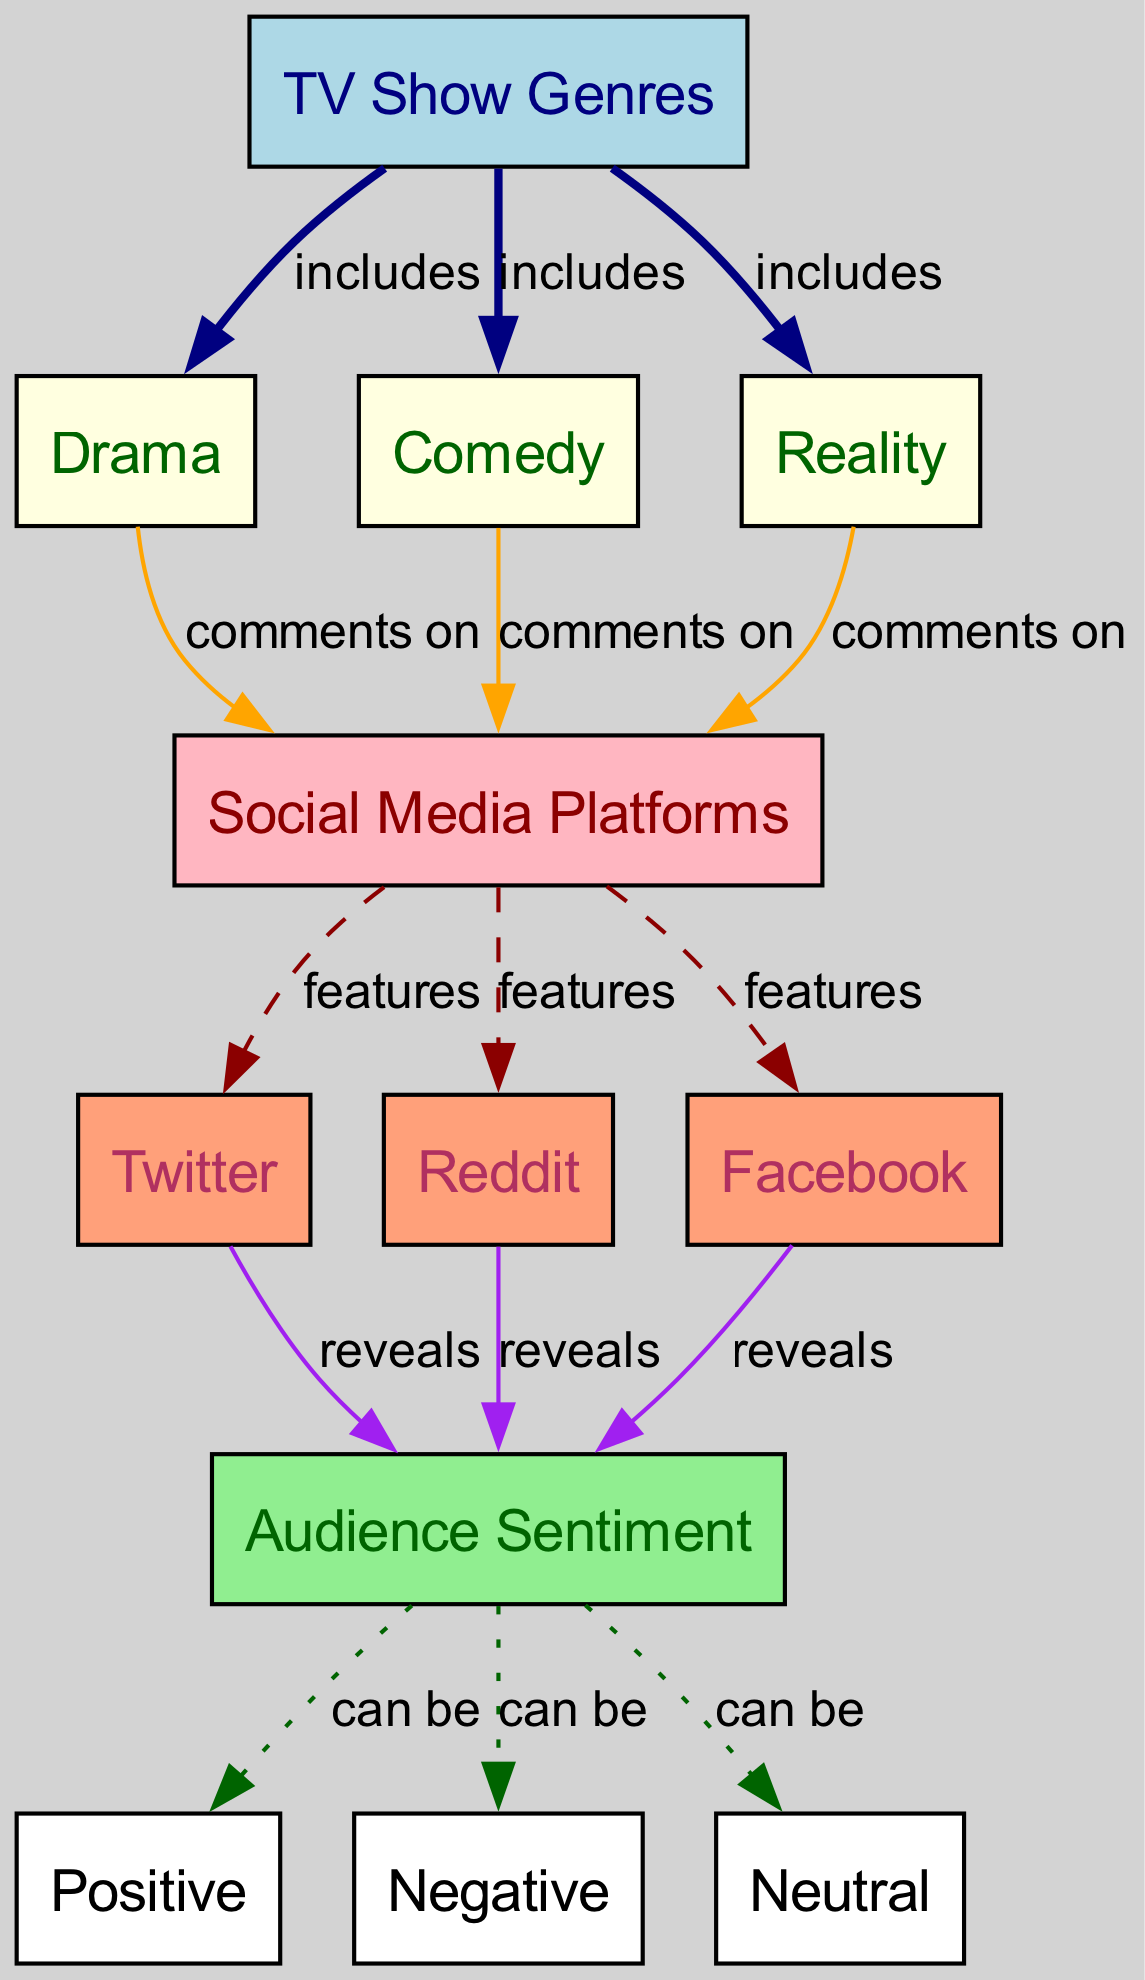What are the three TV show genres listed in the diagram? The diagram identifies three TV show genres: Drama, Comedy, and Reality. These genres are connected to the main node labeled "TV Show Genres," indicating that they are included within that category.
Answer: Drama, Comedy, Reality Which social media platform is not included in the diagram? The diagram includes three social media platforms: Twitter, Reddit, and Facebook. If we consider common platforms, Instagram is a notable absence, indicating that it is not mentioned in the diagram.
Answer: Instagram How many types of audience sentiment are indicated in the diagram? The diagram lists three types of audience sentiment: Positive, Negative, and Neutral. All these sentiments connect to the main node labeled "Audience Sentiment," confirming the variety recognized in audience reactions.
Answer: Three What is the relationship between Drama and Social Media Platforms? The diagram indicates that Drama "comments on" various social media platforms. This suggests that people express their sentiments related to Drama through comments on platforms like Twitter, Reddit, and Facebook.
Answer: Comments on Which sentiment is revealed by Twitter according to the diagram? The diagram shows that Twitter "reveals" audience sentiment, but it does not specify a type of sentiment. However, since it connects to the "Audience Sentiment" node, it can convey Positive, Negative, or Neutral sentiments expressed in comments related to TV shows.
Answer: Positive, Negative, Neutral Which TV show genre has the most complex sentiment discussions based on social media? All three genres (Drama, Comedy, Reality) have remarks tracked through social media platforms, showing that they can generate complex discussions. Since Drama often evokes a wider range of reactions, it may be inferred to spark the most complexity.
Answer: Drama What type of edges are used to connect the social media platforms to the audience sentiment? The edges that connect social media platforms to audience sentiment are labeled as "reveals," indicating that the platforms are sources for revealing the kinds of sentiments people express regarding different TV show genres.
Answer: Reveals Which type of comments does Reality receive on social media platforms? The diagram connects Reality to social media platforms through the "comments on" relationship, indicating that audience members express their opinions and sentiments about Reality shows on these platforms.
Answer: Comments on 